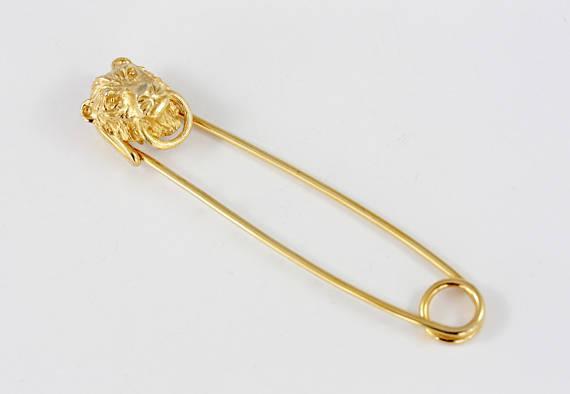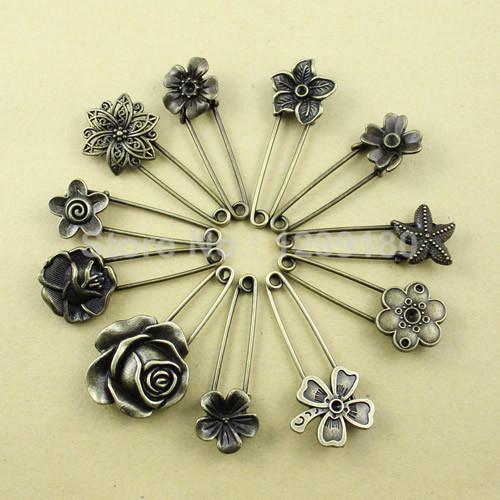The first image is the image on the left, the second image is the image on the right. Analyze the images presented: Is the assertion "The image to the left has a fabric background." valid? Answer yes or no. No. 